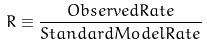Convert formula to latex. <formula><loc_0><loc_0><loc_500><loc_500>R \equiv \frac { O b s e r v e d R a t e } { S t a n d a r d M o d e l R a t e }</formula> 